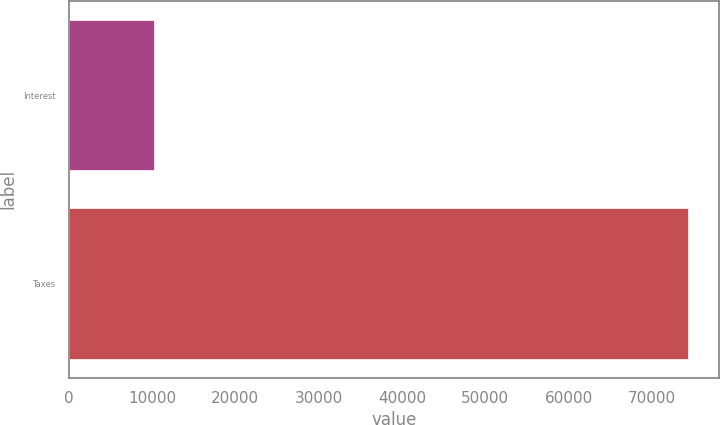<chart> <loc_0><loc_0><loc_500><loc_500><bar_chart><fcel>Interest<fcel>Taxes<nl><fcel>10239<fcel>74333<nl></chart> 